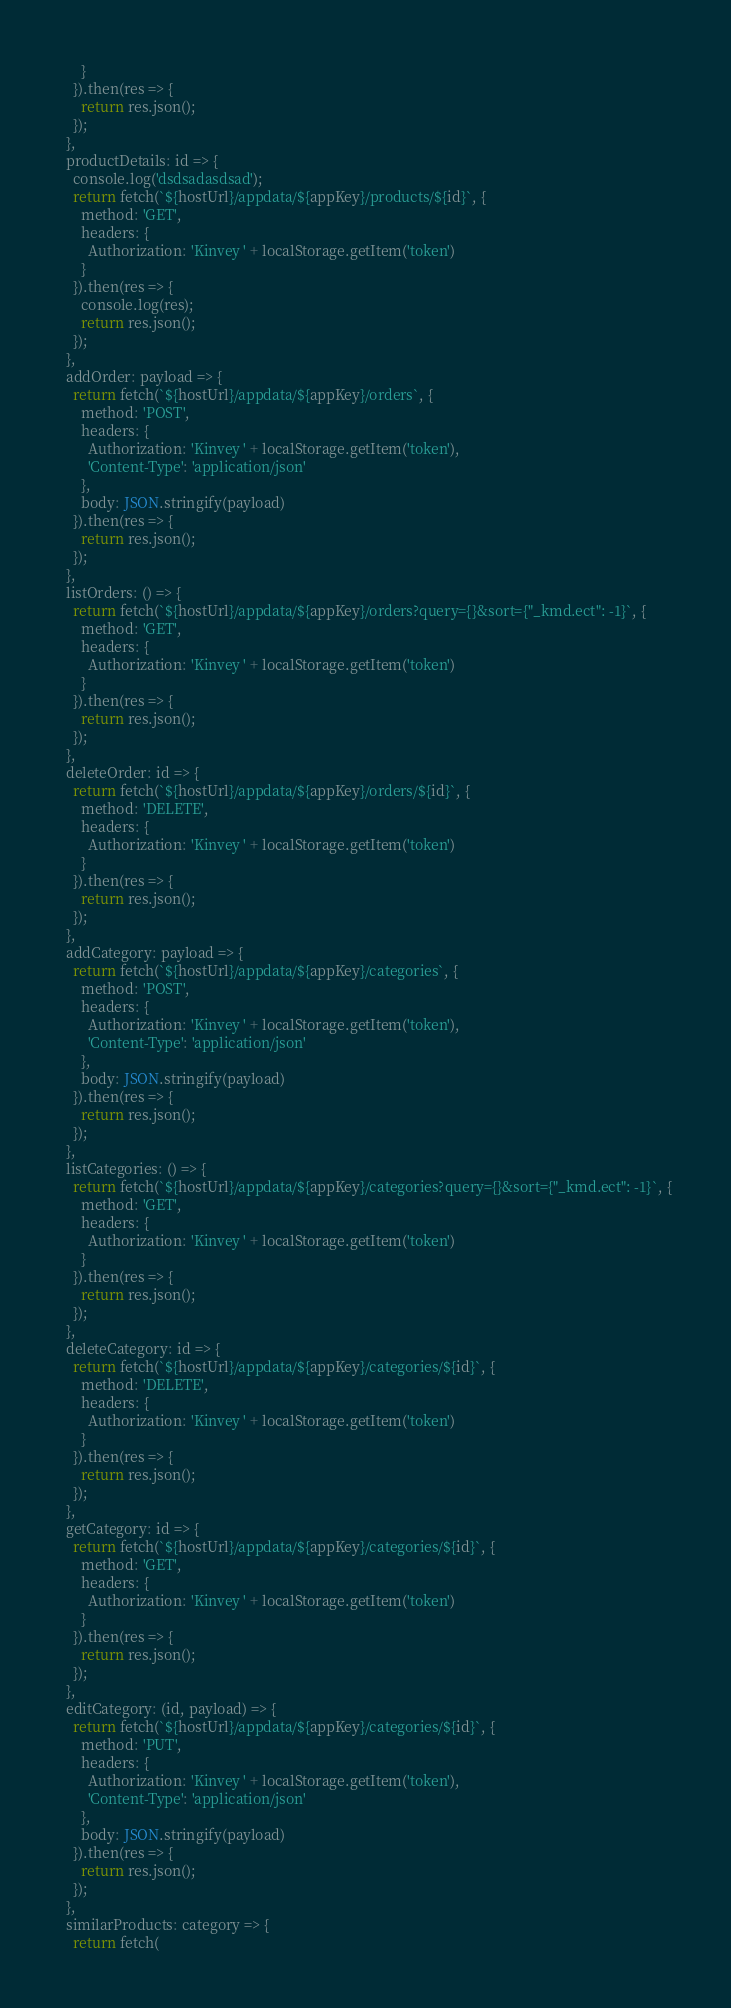Convert code to text. <code><loc_0><loc_0><loc_500><loc_500><_JavaScript_>      }
    }).then(res => {
      return res.json();
    });
  },
  productDetails: id => {
    console.log('dsdsadasdsad');
    return fetch(`${hostUrl}/appdata/${appKey}/products/${id}`, {
      method: 'GET',
      headers: {
        Authorization: 'Kinvey ' + localStorage.getItem('token')
      }
    }).then(res => {
      console.log(res);
      return res.json();
    });
  },
  addOrder: payload => {
    return fetch(`${hostUrl}/appdata/${appKey}/orders`, {
      method: 'POST',
      headers: {
        Authorization: 'Kinvey ' + localStorage.getItem('token'),
        'Content-Type': 'application/json'
      },
      body: JSON.stringify(payload)
    }).then(res => {
      return res.json();
    });
  },
  listOrders: () => {
    return fetch(`${hostUrl}/appdata/${appKey}/orders?query={}&sort={"_kmd.ect": -1}`, {
      method: 'GET',
      headers: {
        Authorization: 'Kinvey ' + localStorage.getItem('token')
      }
    }).then(res => {
      return res.json();
    });
  },
  deleteOrder: id => {
    return fetch(`${hostUrl}/appdata/${appKey}/orders/${id}`, {
      method: 'DELETE',
      headers: {
        Authorization: 'Kinvey ' + localStorage.getItem('token')
      }
    }).then(res => {
      return res.json();
    });
  },
  addCategory: payload => {
    return fetch(`${hostUrl}/appdata/${appKey}/categories`, {
      method: 'POST',
      headers: {
        Authorization: 'Kinvey ' + localStorage.getItem('token'),
        'Content-Type': 'application/json'
      },
      body: JSON.stringify(payload)
    }).then(res => {
      return res.json();
    });
  },
  listCategories: () => {
    return fetch(`${hostUrl}/appdata/${appKey}/categories?query={}&sort={"_kmd.ect": -1}`, {
      method: 'GET',
      headers: {
        Authorization: 'Kinvey ' + localStorage.getItem('token')
      }
    }).then(res => {
      return res.json();
    });
  },
  deleteCategory: id => {
    return fetch(`${hostUrl}/appdata/${appKey}/categories/${id}`, {
      method: 'DELETE',
      headers: {
        Authorization: 'Kinvey ' + localStorage.getItem('token')
      }
    }).then(res => {
      return res.json();
    });
  },
  getCategory: id => {
    return fetch(`${hostUrl}/appdata/${appKey}/categories/${id}`, {
      method: 'GET',
      headers: {
        Authorization: 'Kinvey ' + localStorage.getItem('token')
      }
    }).then(res => {
      return res.json();
    });
  },
  editCategory: (id, payload) => {
    return fetch(`${hostUrl}/appdata/${appKey}/categories/${id}`, {
      method: 'PUT',
      headers: {
        Authorization: 'Kinvey ' + localStorage.getItem('token'),
        'Content-Type': 'application/json'
      },
      body: JSON.stringify(payload)
    }).then(res => {
      return res.json();
    });
  },
  similarProducts: category => {
    return fetch(</code> 